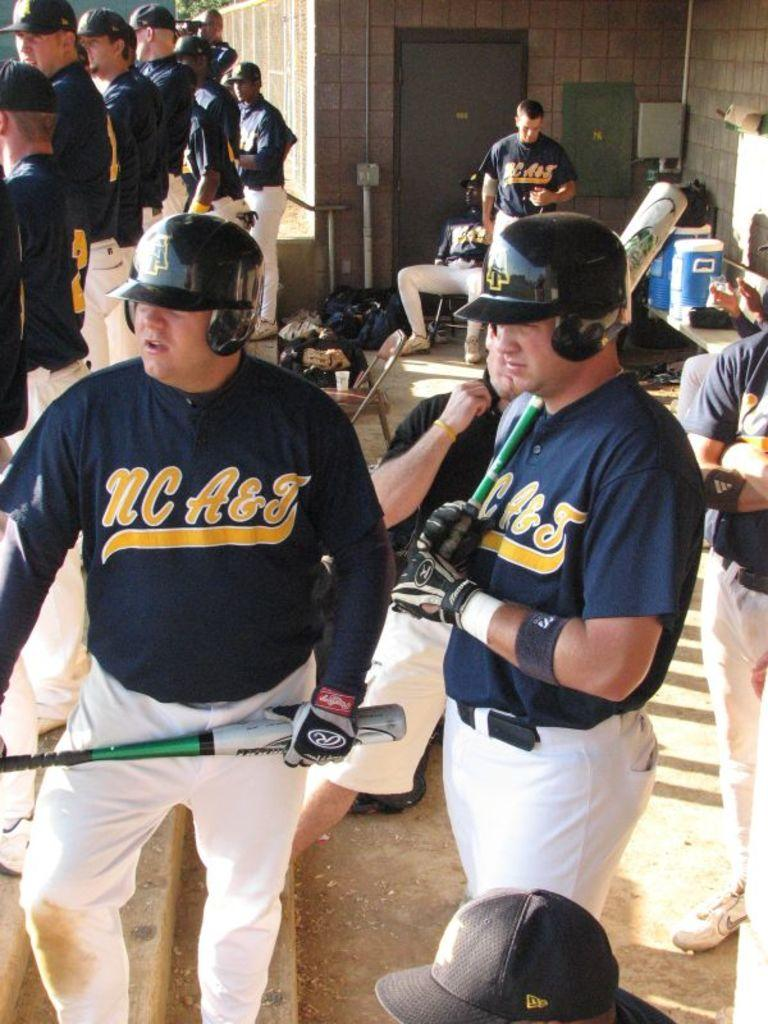<image>
Create a compact narrative representing the image presented. NC A & J baseball players holding bats. 